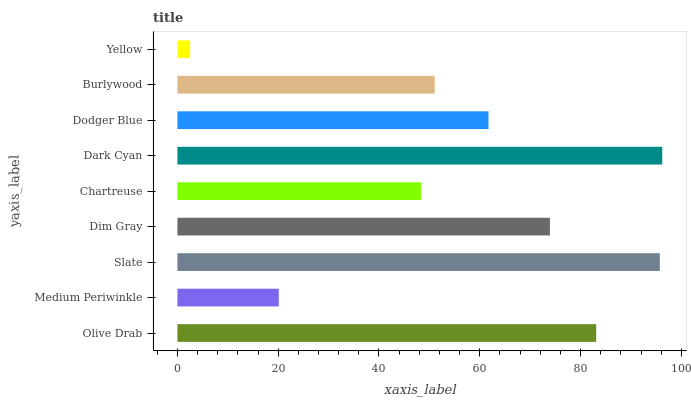Is Yellow the minimum?
Answer yes or no. Yes. Is Dark Cyan the maximum?
Answer yes or no. Yes. Is Medium Periwinkle the minimum?
Answer yes or no. No. Is Medium Periwinkle the maximum?
Answer yes or no. No. Is Olive Drab greater than Medium Periwinkle?
Answer yes or no. Yes. Is Medium Periwinkle less than Olive Drab?
Answer yes or no. Yes. Is Medium Periwinkle greater than Olive Drab?
Answer yes or no. No. Is Olive Drab less than Medium Periwinkle?
Answer yes or no. No. Is Dodger Blue the high median?
Answer yes or no. Yes. Is Dodger Blue the low median?
Answer yes or no. Yes. Is Burlywood the high median?
Answer yes or no. No. Is Burlywood the low median?
Answer yes or no. No. 